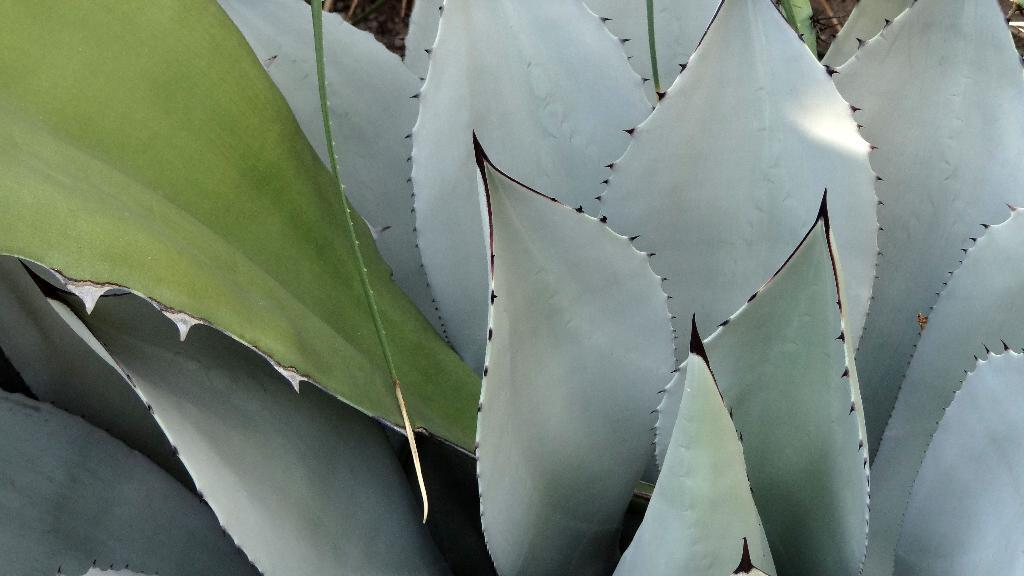Can you describe this image briefly? At the bottom of this image, there are gray color leaves of a plant. On the top left, there are two green color leaves. And the background is blurred. 